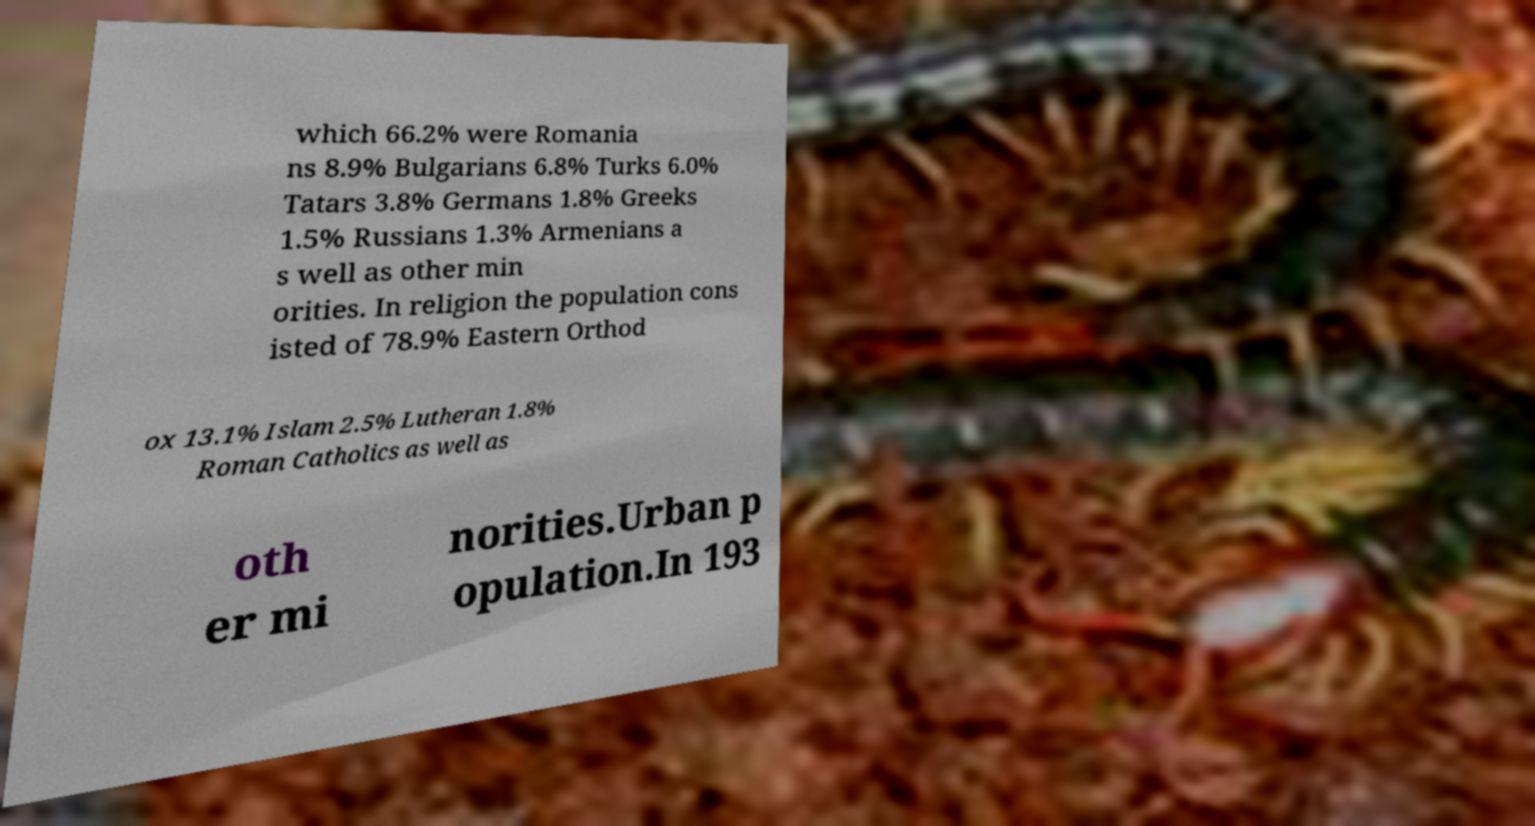Please read and relay the text visible in this image. What does it say? which 66.2% were Romania ns 8.9% Bulgarians 6.8% Turks 6.0% Tatars 3.8% Germans 1.8% Greeks 1.5% Russians 1.3% Armenians a s well as other min orities. In religion the population cons isted of 78.9% Eastern Orthod ox 13.1% Islam 2.5% Lutheran 1.8% Roman Catholics as well as oth er mi norities.Urban p opulation.In 193 